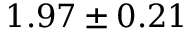<formula> <loc_0><loc_0><loc_500><loc_500>1 . 9 7 \pm 0 . 2 1</formula> 